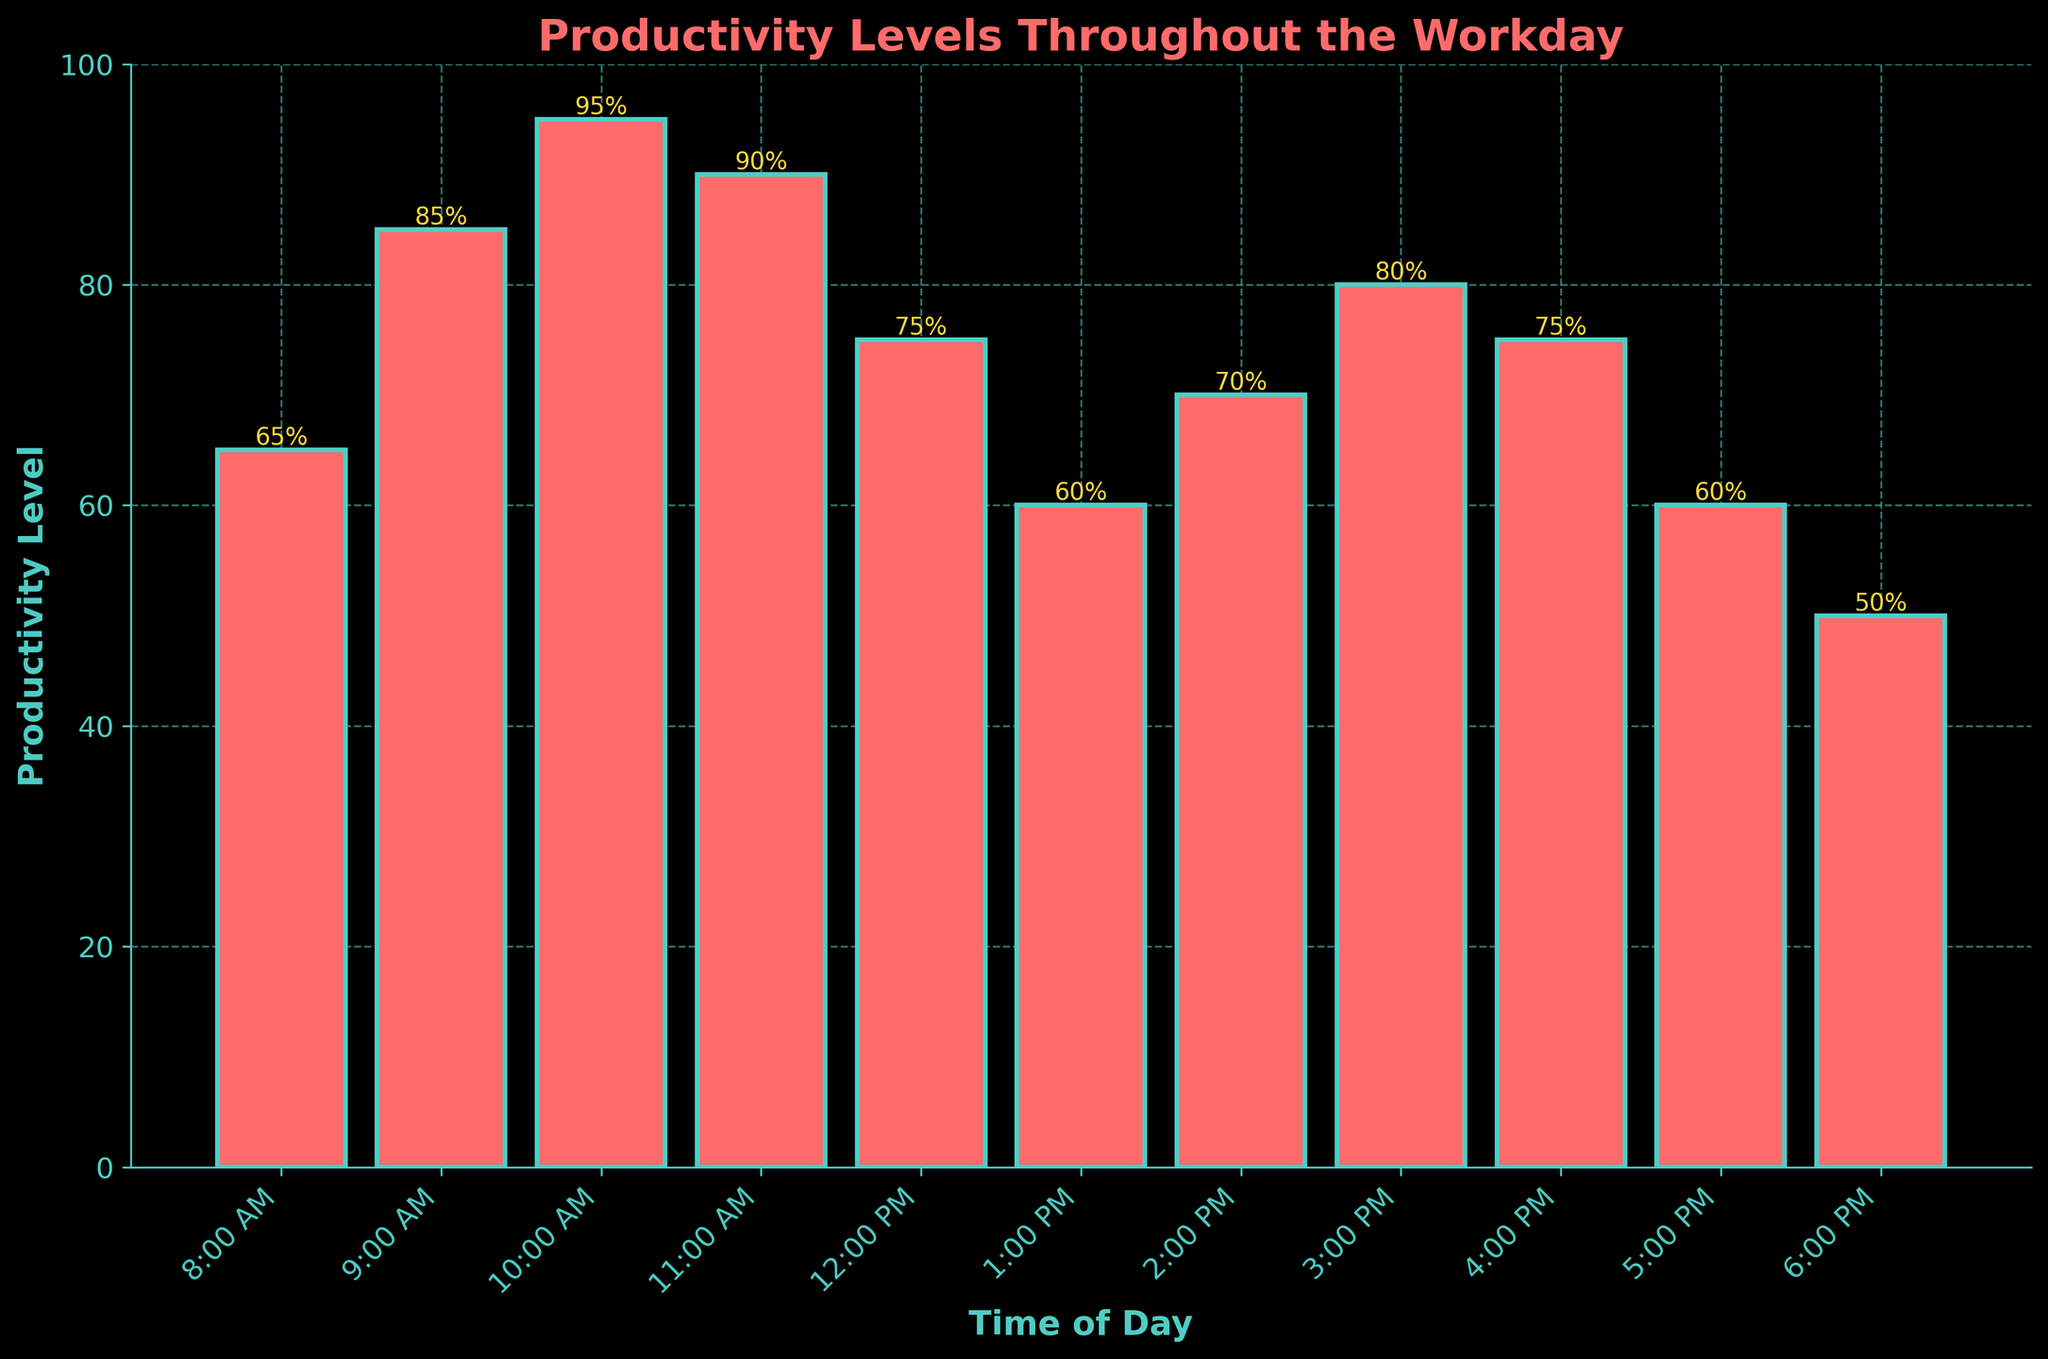What time shows the highest productivity level? Observing the bar chart, the tallest bar represents the highest productivity level at a certain time. The 10:00 AM bar is the highest, corresponding to a productivity level of 95%.
Answer: 10:00 AM What is the total productivity level from 2:00 PM to 4:00 PM? Summing the productivity levels for 2:00 PM (70), 3:00 PM (80), and 4:00 PM (75): 70 + 80 + 75 = 225.
Answer: 225 How does the productivity at 1:00 PM compare to 11:00 AM? Compare the heights of the bars for 1:00 PM and 11:00 AM. The bar for 1:00 PM is shorter at a productivity level of 60%, whereas the 11:00 AM bar has a higher productivity level of 90%.
Answer: 1:00 PM is less productive Which period shows the lowest productivity level and what is it? Identify the shortest bar, which corresponds to the lowest productivity level. The bar for 6:00 PM is the shortest, representing a productivity level of 50%.
Answer: 6:00 PM, 50% What is the average productivity level between 8:00 AM and 12:00 PM? Calculate the average by adding the productivity levels from 8:00 AM (65), 9:00 AM (85), 10:00 AM (95), 11:00 AM (90), and 12:00 PM (75) and dividing by 5: (65 + 85 + 95 + 90 + 75) / 5 = 82.
Answer: 82 Between which hours does the productivity drop significantly around lunchtime? Check the bars before and after lunchtime (12:00 PM). The productivity drops significantly from 11:00 AM (90%) to 12:00 PM (75%), and then further to 1:00 PM (60%).
Answer: 11:00 AM to 1:00 PM What is the difference in productivity between 8:00 AM and 5:00 PM? Calculate the difference between the productivity levels at 8:00 AM (65) and 5:00 PM (60): 65 - 60 = 5.
Answer: 5 What is the total productivity level observed from 8:00 AM to 6:00 PM? Sum up all the productivity levels from 8:00 AM to 6:00 PM: 65 + 85 + 95 + 90 + 75 + 60 + 70 + 80 + 75 + 60 + 50 = 805.
Answer: 805 In which hour does the productivity level return to 75% after lunch? Identify the times where the productivity level is 75%. After lunch (12:00 PM with 75%), the next occurrence is at 4:00 PM.
Answer: 4:00 PM 